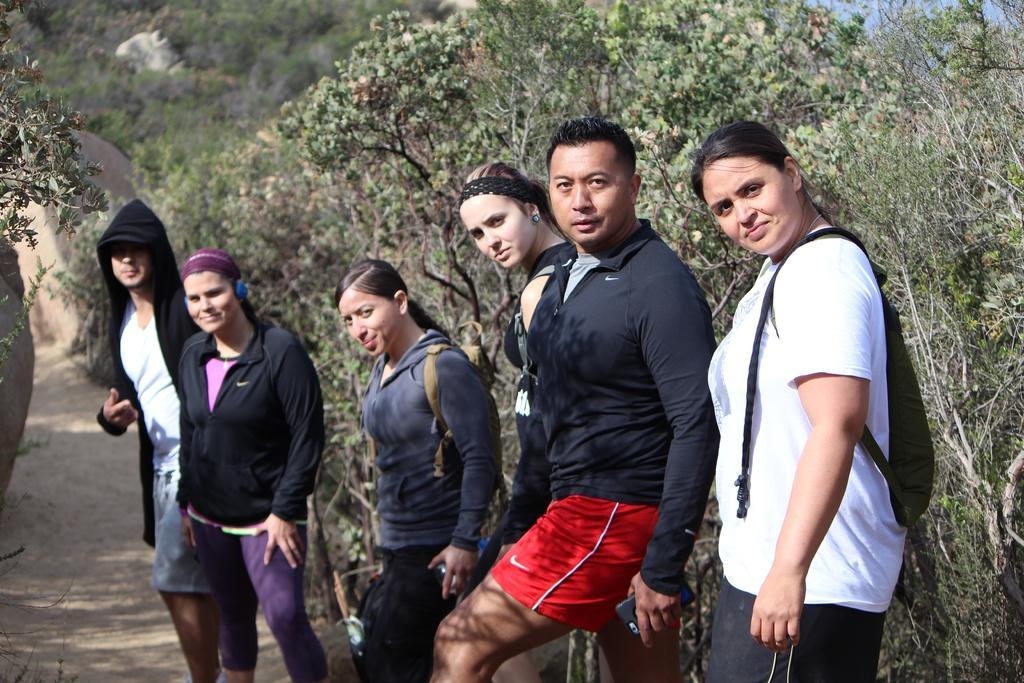Can you describe this image briefly? In this image, we can see people wearing coats and some are wearing bags and holding objects. In the background, there are trees and rocks. At the bottom, there is ground. 